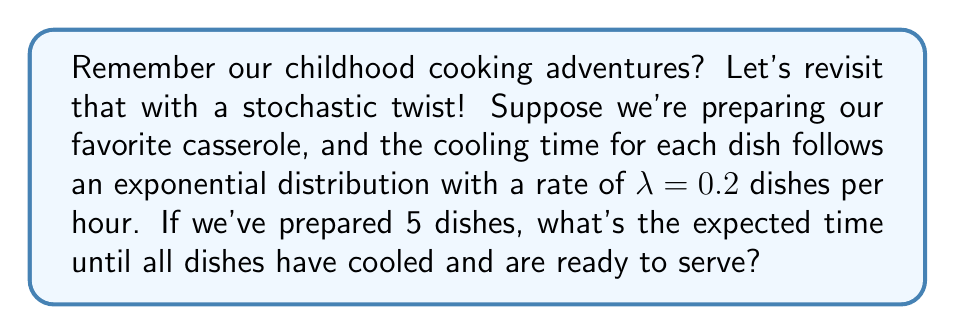Can you answer this question? Let's approach this step-by-step:

1) First, recall that for an exponential distribution with rate $\lambda$, the expected value (mean) is $\frac{1}{\lambda}$.

2) In this case, $\lambda = 0.2$ dishes/hour, so the expected cooling time for one dish is:

   $E[X] = \frac{1}{\lambda} = \frac{1}{0.2} = 5$ hours

3) Now, we need to find the expected time for all 5 dishes to cool. This is equivalent to finding the expected maximum of 5 independent exponential random variables.

4) For $n$ independent exponential random variables with rate $\lambda$, the expected maximum is given by the formula:

   $E[\max(X_1, ..., X_n)] = \frac{1}{\lambda} \sum_{i=1}^n \frac{1}{i}$

5) In our case, $n = 5$ and $\lambda = 0.2$, so:

   $E[\max(X_1, ..., X_5)] = \frac{1}{0.2} \sum_{i=1}^5 \frac{1}{i}$

6) Let's calculate the sum:

   $\sum_{i=1}^5 \frac{1}{i} = 1 + \frac{1}{2} + \frac{1}{3} + \frac{1}{4} + \frac{1}{5} = 2.283333...$

7) Now, we can complete the calculation:

   $E[\max(X_1, ..., X_5)] = \frac{1}{0.2} \cdot 2.283333... = 5 \cdot 2.283333... = 11.416666...$

Therefore, the expected time until all 5 dishes have cooled is approximately 11.42 hours.
Answer: 11.42 hours 